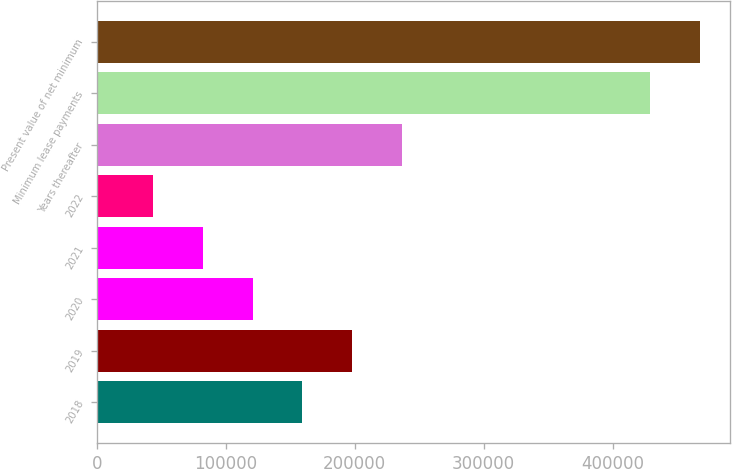Convert chart. <chart><loc_0><loc_0><loc_500><loc_500><bar_chart><fcel>2018<fcel>2019<fcel>2020<fcel>2021<fcel>2022<fcel>Years thereafter<fcel>Minimum lease payments<fcel>Present value of net minimum<nl><fcel>159358<fcel>197890<fcel>120825<fcel>82292.6<fcel>43760<fcel>236423<fcel>429086<fcel>467619<nl></chart> 